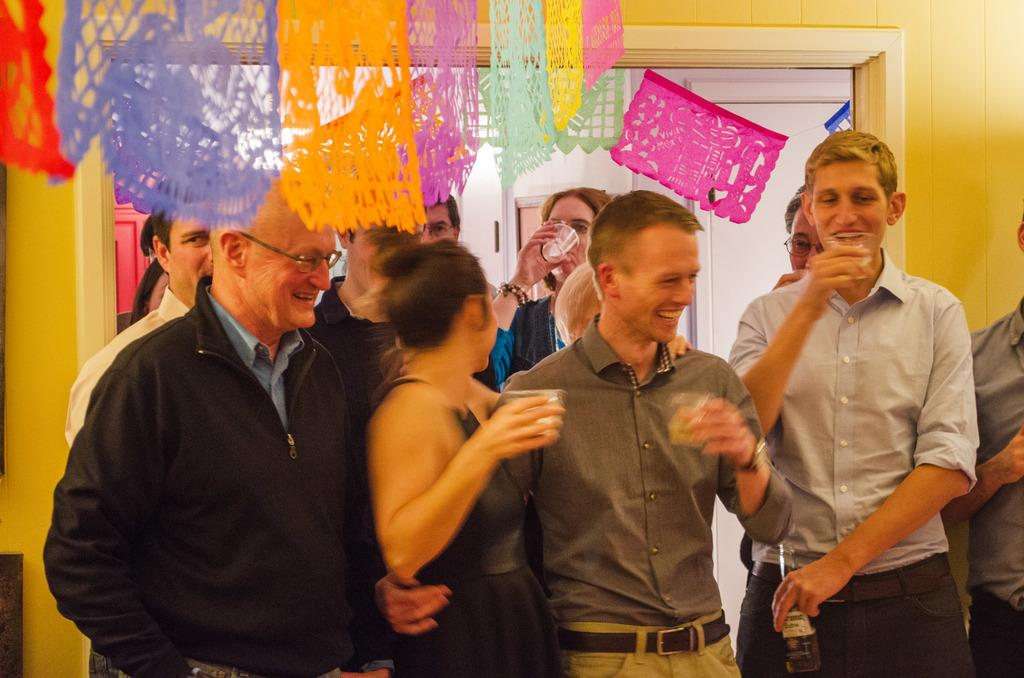What are the people in the image doing? The people in the image are standing and smiling. What are some people holding in the image? Some people are holding glasses in the image. What can be seen in the background of the image? There are decorative papers hanging, a door, and a wall in the background of the image. What type of list can be seen on the edge of the door in the image? There is no list present on the edge of the door in the image. 